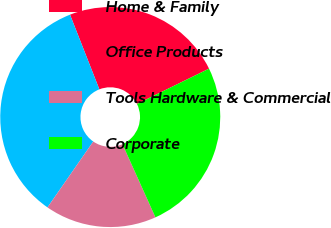Convert chart. <chart><loc_0><loc_0><loc_500><loc_500><pie_chart><fcel>Home & Family<fcel>Office Products<fcel>Tools Hardware & Commercial<fcel>Corporate<nl><fcel>23.71%<fcel>34.38%<fcel>16.4%<fcel>25.51%<nl></chart> 